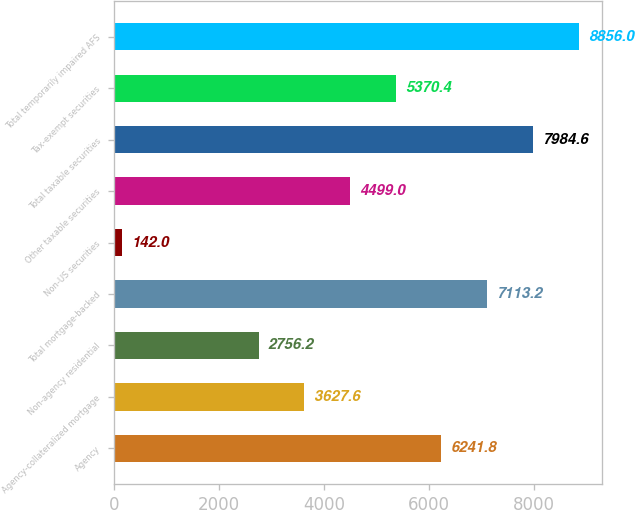Convert chart. <chart><loc_0><loc_0><loc_500><loc_500><bar_chart><fcel>Agency<fcel>Agency-collateralized mortgage<fcel>Non-agency residential<fcel>Total mortgage-backed<fcel>Non-US securities<fcel>Other taxable securities<fcel>Total taxable securities<fcel>Tax-exempt securities<fcel>Total temporarily impaired AFS<nl><fcel>6241.8<fcel>3627.6<fcel>2756.2<fcel>7113.2<fcel>142<fcel>4499<fcel>7984.6<fcel>5370.4<fcel>8856<nl></chart> 